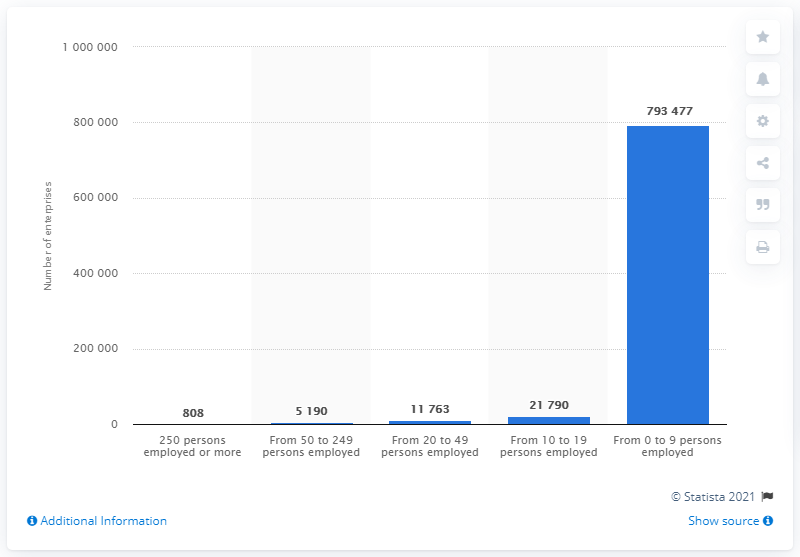Give some essential details in this illustration. In 2016, there were 808 enterprises in Portugal with 250 or more employees. 